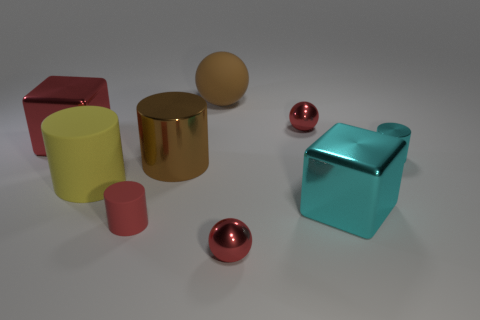Are the shapes in the image more mathematical or organic? The shapes in this image are predominantly mathematical, characterized by clean, precise edges and uniform surfaces, typical of geometric forms such as cylinders and spheres. What might the arrangement of these objects tell us? The arrangement of the objects seems intentional but without a clear pattern. It may suggest an abstract composition or be a setting for a study on light reflection and materials. 